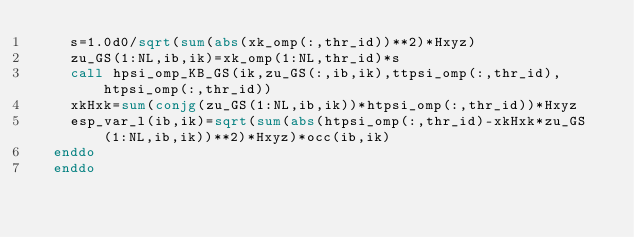<code> <loc_0><loc_0><loc_500><loc_500><_FORTRAN_>    s=1.0d0/sqrt(sum(abs(xk_omp(:,thr_id))**2)*Hxyz)
    zu_GS(1:NL,ib,ik)=xk_omp(1:NL,thr_id)*s
    call hpsi_omp_KB_GS(ik,zu_GS(:,ib,ik),ttpsi_omp(:,thr_id),htpsi_omp(:,thr_id))
    xkHxk=sum(conjg(zu_GS(1:NL,ib,ik))*htpsi_omp(:,thr_id))*Hxyz
    esp_var_l(ib,ik)=sqrt(sum(abs(htpsi_omp(:,thr_id)-xkHxk*zu_GS(1:NL,ib,ik))**2)*Hxyz)*occ(ib,ik)
  enddo
  enddo
</code> 